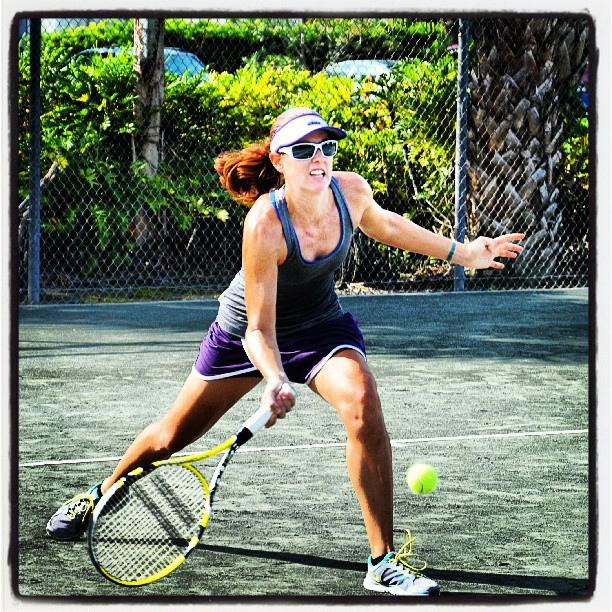What sport is the lady playing?
Concise answer only. Tennis. Is she wearing a cap?
Be succinct. No. Is her racquet going to scrape the ground?
Give a very brief answer. No. 